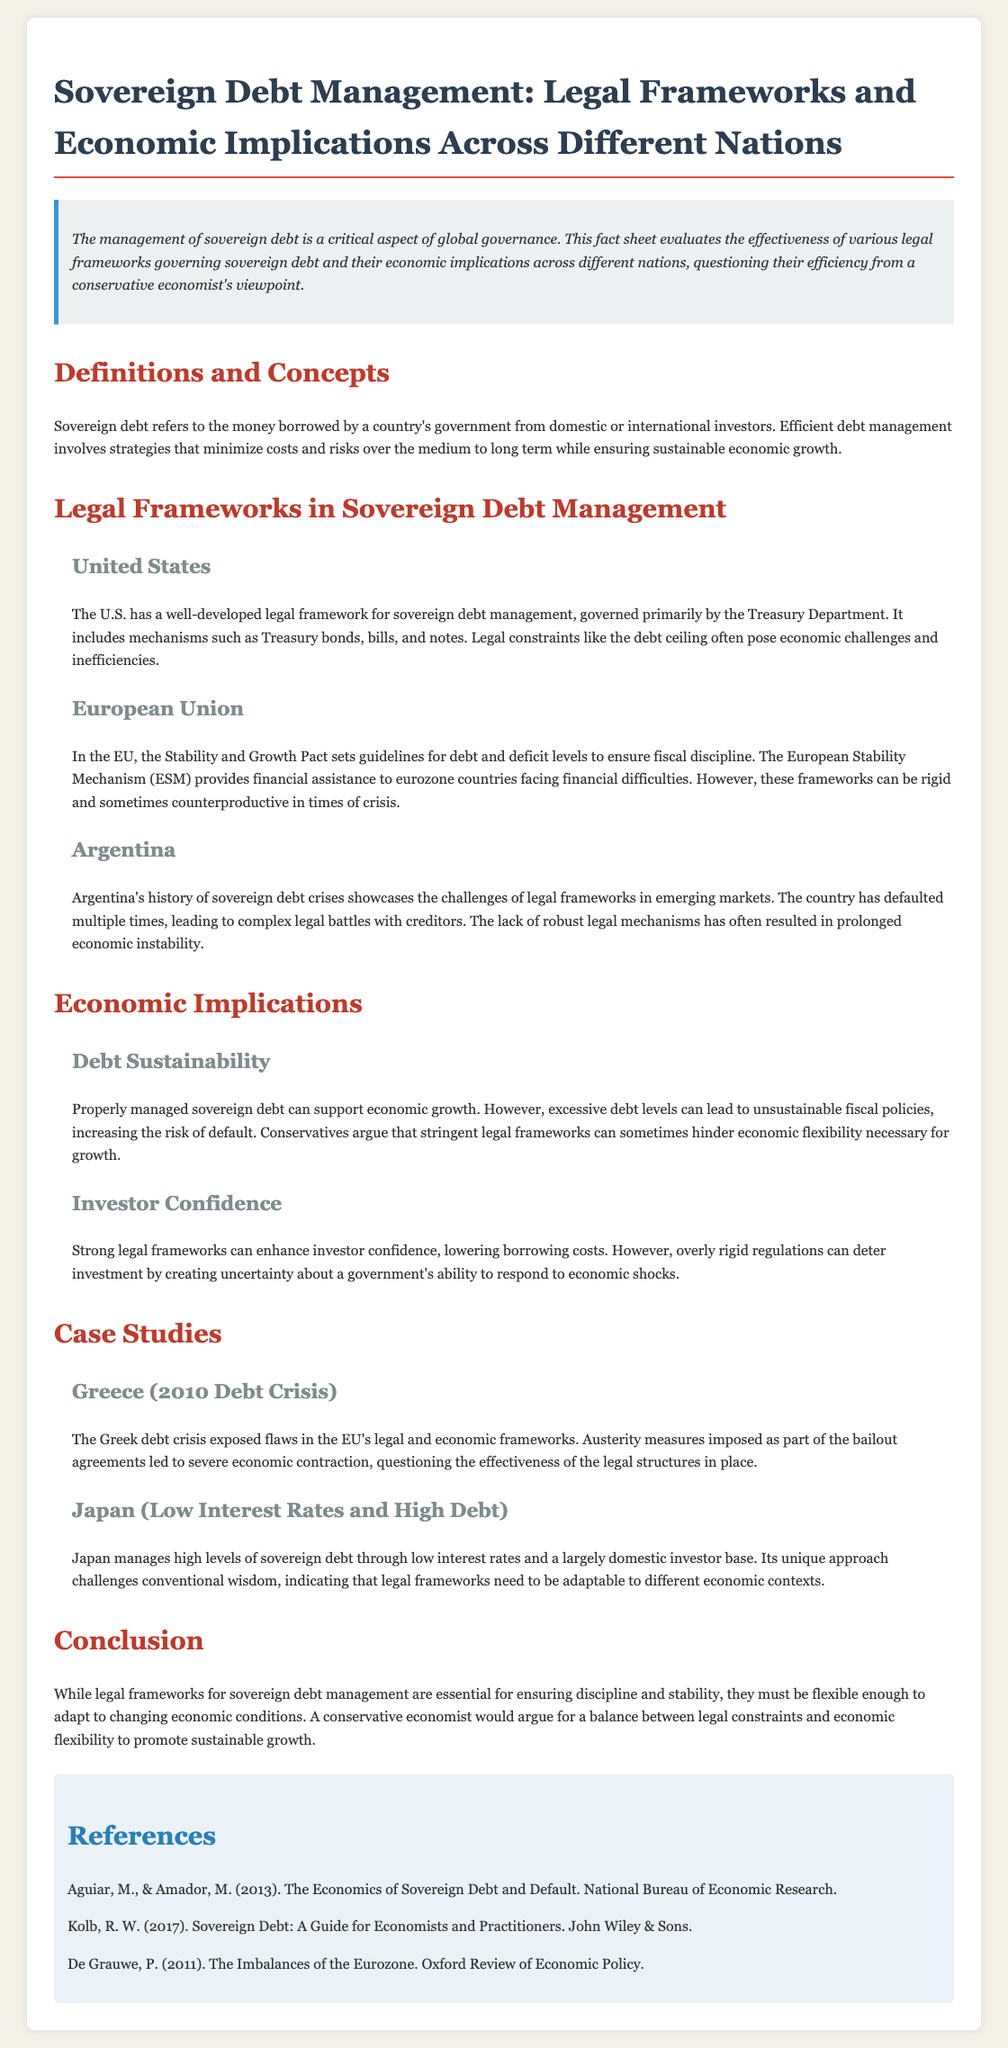What is sovereign debt? Sovereign debt is defined in the document as money borrowed by a country's government from domestic or international investors.
Answer: Money borrowed by a country's government What legal mechanism does the U.S. use for sovereign debt management? The U.S. primarily uses Treasury bonds, bills, and notes for sovereign debt management as stated in the document.
Answer: Treasury bonds, bills, and notes What is the main guideline for fiscal discipline in the European Union? The document mentions the Stability and Growth Pact as the main guideline for maintaining fiscal discipline in the EU.
Answer: Stability and Growth Pact What country has defaulted multiple times on its sovereign debt? The document cites Argentina as a country that has defaulted multiple times on its sovereign debt.
Answer: Argentina What does the document suggest about the relationship between legal frameworks and economic flexibility? It argues that stringent legal frameworks can sometimes hinder the economic flexibility necessary for growth.
Answer: Hinder economic flexibility How did austerity measures impact the Greek economy during the 2010 debt crisis? The document states that austerity measures led to severe economic contraction in Greece during the 2010 debt crisis.
Answer: Severe economic contraction What is one unique method Japan uses to manage its sovereign debt? The document highlights that Japan manages its high levels of sovereign debt through low interest rates.
Answer: Low interest rates What is the conclusion regarding legal frameworks for sovereign debt management? The conclusion in the document is that legal frameworks must be flexible to adapt to changing economic conditions.
Answer: Must be flexible 